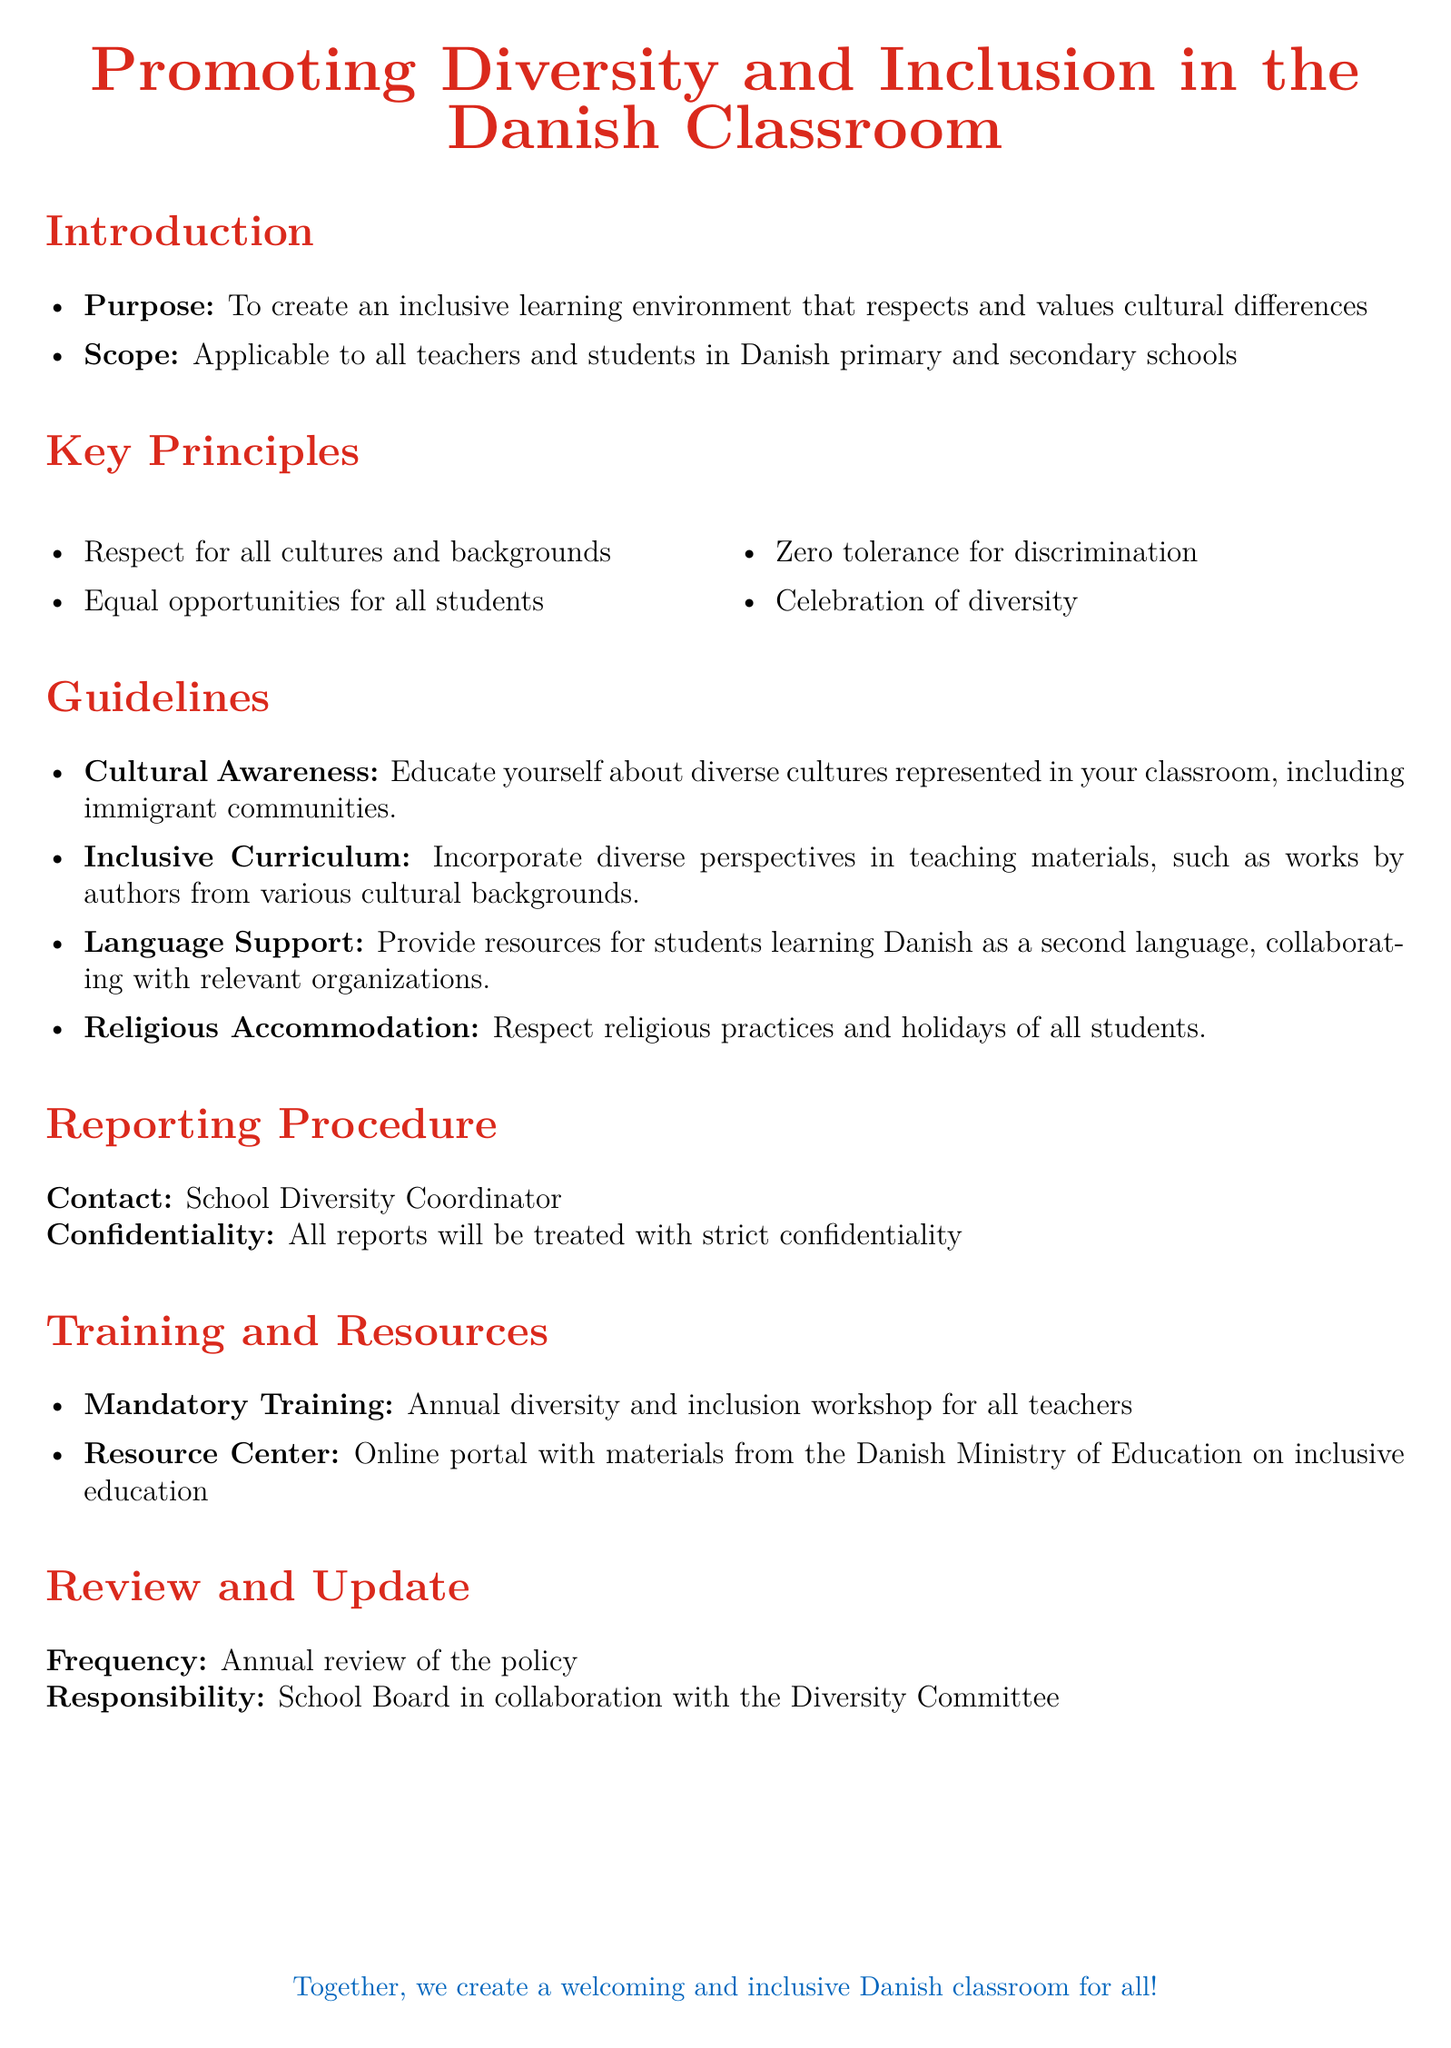What is the purpose of the policy? The purpose is to create an inclusive learning environment that respects and values cultural differences.
Answer: To create an inclusive learning environment What are the key principles listed in the policy? The key principles include respect for all cultures and backgrounds, equal opportunities for all students, zero tolerance for discrimination, and celebration of diversity.
Answer: Respect for all cultures, equal opportunities, zero tolerance for discrimination, celebration of diversity Who is the contact person for reporting incidents? The document specifies the School Diversity Coordinator as the contact person for reporting incidents.
Answer: School Diversity Coordinator What is the frequency of the policy review? The policy is to be reviewed annually, as stated in the document.
Answer: Annual What type of training is mandatory for teachers? The document mentions an annual diversity and inclusion workshop as the mandatory training for all teachers.
Answer: Annual diversity and inclusion workshop What does the guideline for cultural awareness entail? It involves educating oneself about diverse cultures represented in the classroom, including immigrant communities.
Answer: Educate yourself about diverse cultures What resource is provided for language support? The policy specifies resources for students learning Danish as a second language.
Answer: Resources for students learning Danish What is the responsibility for the policy review? The responsibility for the policy review lies with the School Board in collaboration with the Diversity Committee.
Answer: School Board and Diversity Committee 